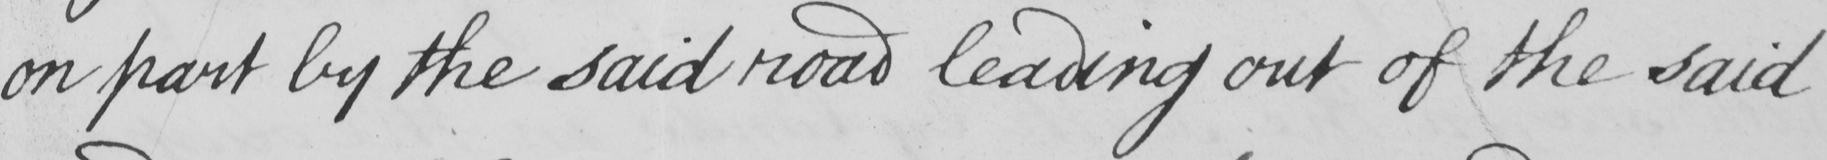Can you read and transcribe this handwriting? on part by the said road leading out of the said 